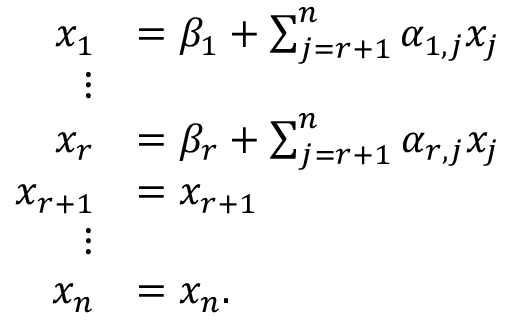<formula> <loc_0><loc_0><loc_500><loc_500>{ \begin{array} { r l } { x _ { 1 } } & { = \beta _ { 1 } + \sum _ { j = r + 1 } ^ { n } \alpha _ { 1 , j } x _ { j } } \\ { \vdots } \\ { x _ { r } } & { = \beta _ { r } + \sum _ { j = r + 1 } ^ { n } \alpha _ { r , j } x _ { j } } \\ { x _ { r + 1 } } & { = x _ { r + 1 } } \\ { \vdots } \\ { x _ { n } } & { = x _ { n } . } \end{array} }</formula> 